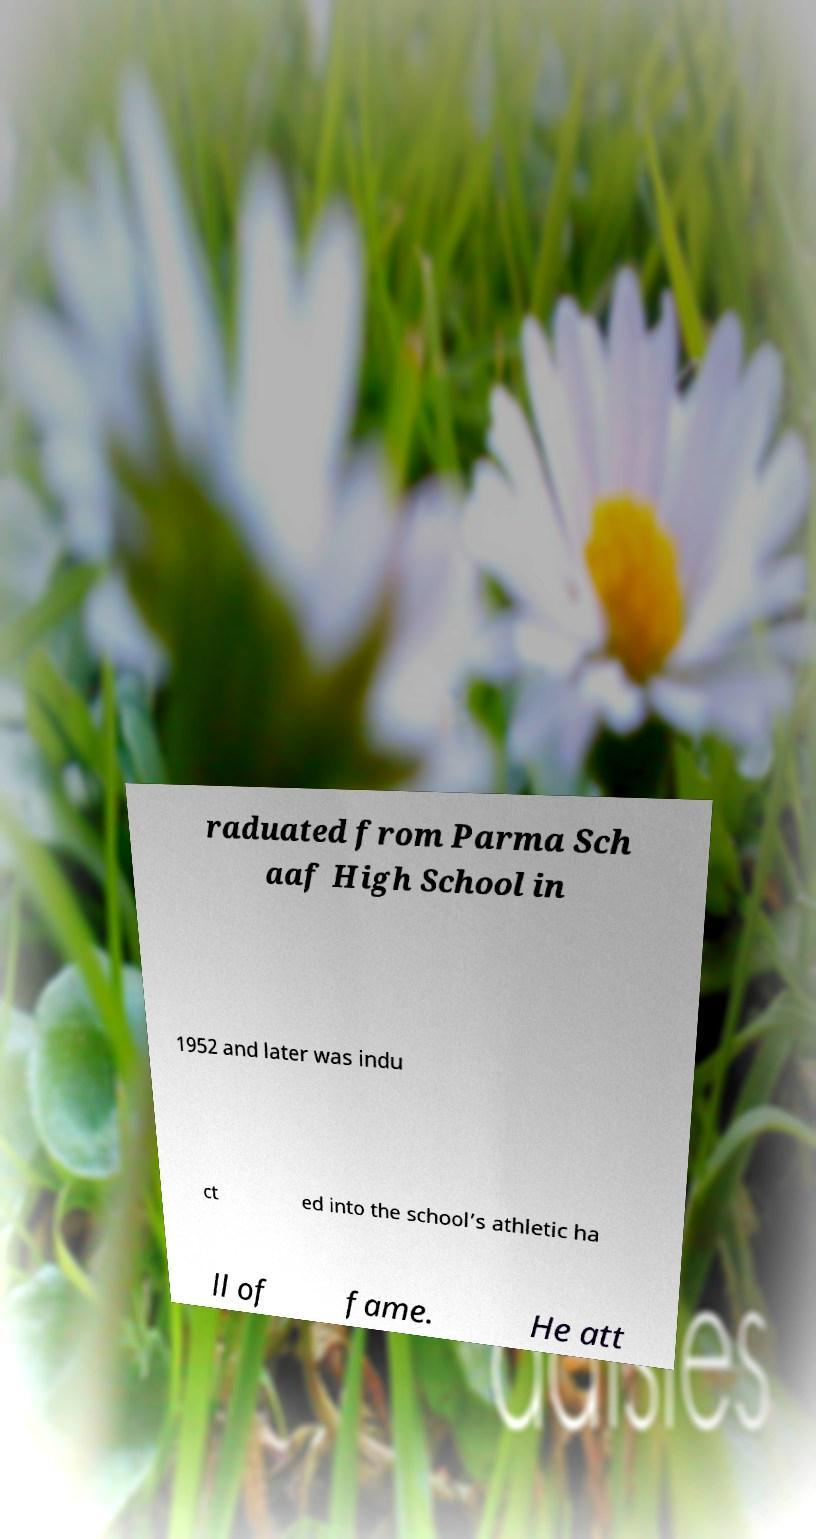Could you extract and type out the text from this image? raduated from Parma Sch aaf High School in 1952 and later was indu ct ed into the school’s athletic ha ll of fame. He att 